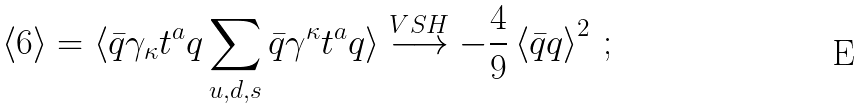<formula> <loc_0><loc_0><loc_500><loc_500>\left < 6 \right > = \langle \bar { q } \gamma _ { \kappa } t ^ { a } q \sum _ { u , d , s } \bar { q } \gamma ^ { \kappa } t ^ { a } q \rangle \stackrel { V S H } { \longrightarrow } - \frac { 4 } { 9 } \left < \bar { q } q \right > ^ { 2 } \, ;</formula> 